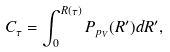Convert formula to latex. <formula><loc_0><loc_0><loc_500><loc_500>C _ { \tau } = \int ^ { R ( \tau ) } _ { 0 } P _ { p _ { V } } ( R ^ { \prime } ) d R ^ { \prime } ,</formula> 